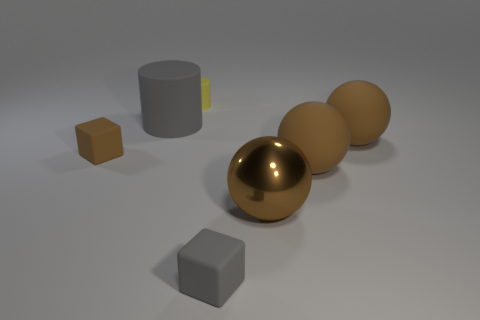How does the arrangement of objects contribute to the composition? The objects are spaced in a manner that draws the eye from the front to the back of the image, creating depth. The cylindrical object anchors the composition on the left, while the line of spheres leads the viewer's gaze across the scene, making for a balanced and visually appealing arrangement. 